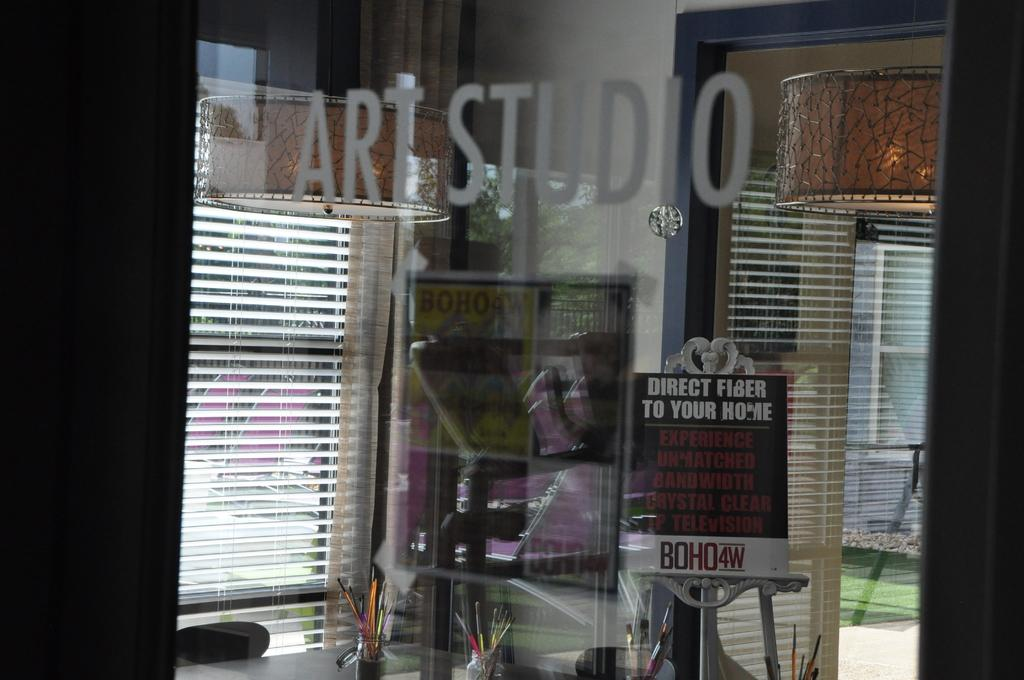What is on the glass in the image? There are stickers on the glass. What can be seen through the glass? A hoarding and a white wall are visible through the glass. What is on the table in the image? Flower vases are present on a table. What is the ground made of in the image? Grass is on the ground. What type of furniture is visible in the image? Chairs are visible in the image. Can you describe any other objects present in the image? Other objects are present in the image, but their specific details are not mentioned in the provided facts. What type of humor can be seen in the image? There is no humor present in the image; it features stickers on a glass, a hoarding and a white wall visible through the glass, flower vases on a table, grass on the ground, chairs, and other unspecified objects. Are there any mountains visible in the image? There are no mountains present in the image. 